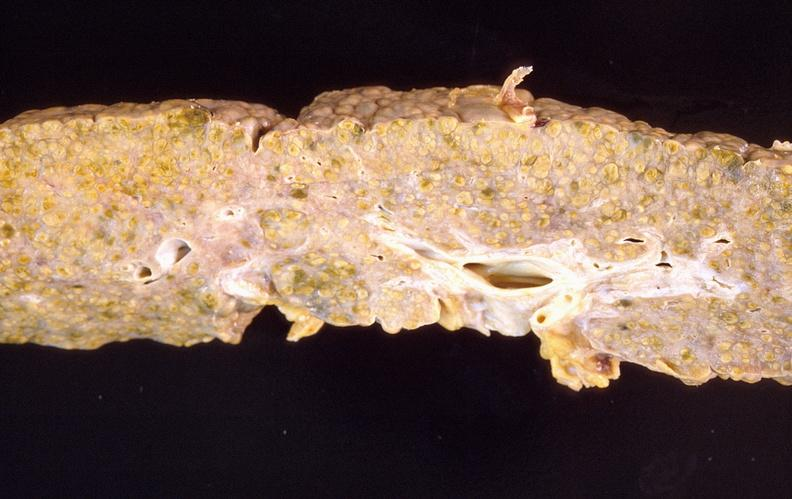what does this image show?
Answer the question using a single word or phrase. Liver cirrhosis 